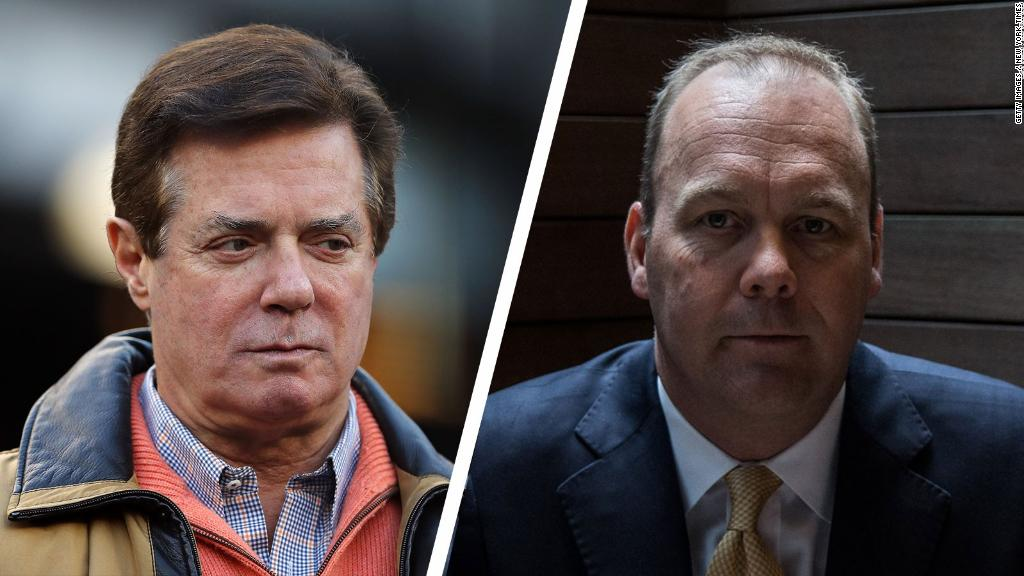What might be the professions of these two individuals based on their attire? Based on their attire, the man on the left appears to be engaged in a profession that allows for a smart-casual dress code. His combination of a jacket and a checked shirt suggests he might be a business owner, an executive in a startup, or in a sector where there is a balance between professionalism and approachability.

On the other hand, the man on the right, dressed in a suit, white shirt, and tie, presents a more formal appearance. This attire is typical for professions in corporate sectors, law, finance, or politics, where traditional business attire is often required. The suit and tie indicate a role that involves formal interactions and possibly positions of authority. 